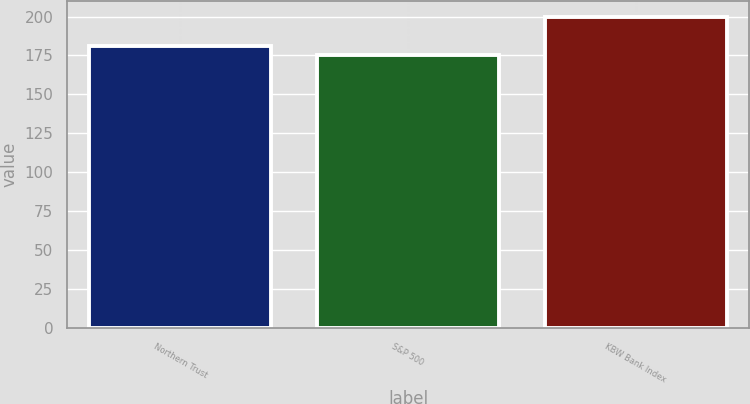Convert chart. <chart><loc_0><loc_0><loc_500><loc_500><bar_chart><fcel>Northern Trust<fcel>S&P 500<fcel>KBW Bank Index<nl><fcel>181<fcel>175<fcel>200<nl></chart> 